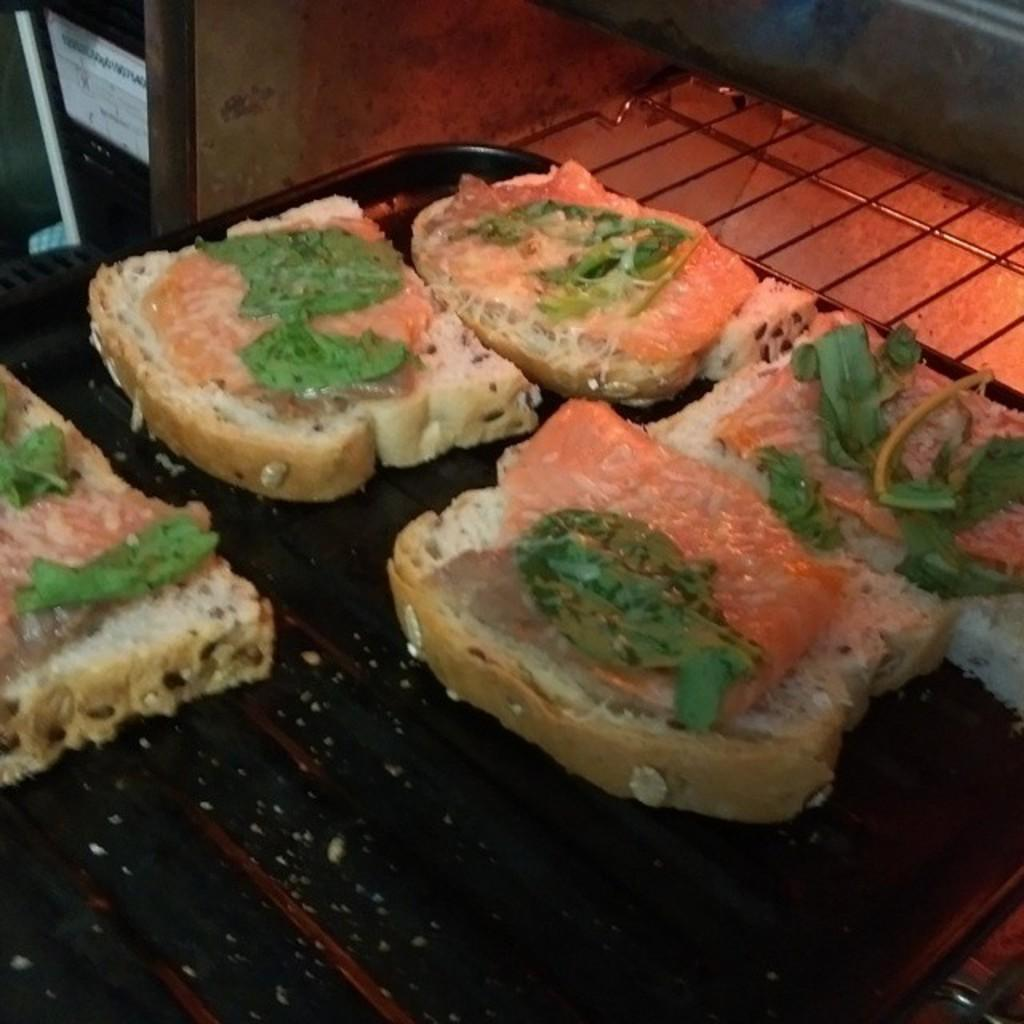What color is the plate in the image? The plate in the image is black. What is on the plate? There are dreads on the plate. Are there any additional elements on the dreads? Yes, there are green leaves on the dreads. Can you see a bit of the stream in the image? There is no stream present in the image. 